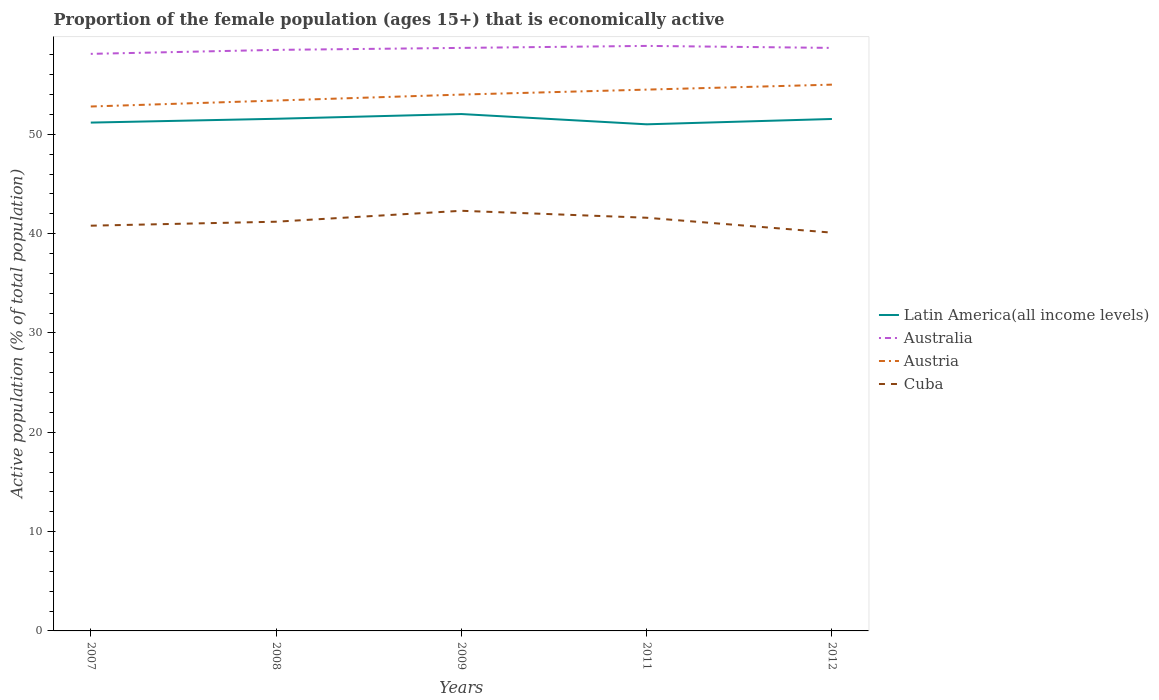Does the line corresponding to Latin America(all income levels) intersect with the line corresponding to Austria?
Offer a very short reply. No. Is the number of lines equal to the number of legend labels?
Make the answer very short. Yes. Across all years, what is the maximum proportion of the female population that is economically active in Australia?
Offer a very short reply. 58.1. What is the difference between the highest and the second highest proportion of the female population that is economically active in Latin America(all income levels)?
Offer a terse response. 1.03. What is the difference between the highest and the lowest proportion of the female population that is economically active in Austria?
Your answer should be compact. 3. How many years are there in the graph?
Offer a very short reply. 5. What is the difference between two consecutive major ticks on the Y-axis?
Make the answer very short. 10. Are the values on the major ticks of Y-axis written in scientific E-notation?
Provide a succinct answer. No. Where does the legend appear in the graph?
Your response must be concise. Center right. How many legend labels are there?
Make the answer very short. 4. How are the legend labels stacked?
Provide a succinct answer. Vertical. What is the title of the graph?
Offer a terse response. Proportion of the female population (ages 15+) that is economically active. Does "Malaysia" appear as one of the legend labels in the graph?
Offer a very short reply. No. What is the label or title of the Y-axis?
Your answer should be compact. Active population (% of total population). What is the Active population (% of total population) of Latin America(all income levels) in 2007?
Ensure brevity in your answer.  51.18. What is the Active population (% of total population) in Australia in 2007?
Keep it short and to the point. 58.1. What is the Active population (% of total population) of Austria in 2007?
Offer a very short reply. 52.8. What is the Active population (% of total population) in Cuba in 2007?
Make the answer very short. 40.8. What is the Active population (% of total population) in Latin America(all income levels) in 2008?
Your answer should be very brief. 51.56. What is the Active population (% of total population) of Australia in 2008?
Give a very brief answer. 58.5. What is the Active population (% of total population) of Austria in 2008?
Offer a terse response. 53.4. What is the Active population (% of total population) of Cuba in 2008?
Your response must be concise. 41.2. What is the Active population (% of total population) of Latin America(all income levels) in 2009?
Provide a succinct answer. 52.04. What is the Active population (% of total population) of Australia in 2009?
Offer a terse response. 58.7. What is the Active population (% of total population) in Austria in 2009?
Provide a short and direct response. 54. What is the Active population (% of total population) of Cuba in 2009?
Provide a short and direct response. 42.3. What is the Active population (% of total population) of Latin America(all income levels) in 2011?
Give a very brief answer. 51.01. What is the Active population (% of total population) of Australia in 2011?
Your answer should be very brief. 58.9. What is the Active population (% of total population) in Austria in 2011?
Keep it short and to the point. 54.5. What is the Active population (% of total population) of Cuba in 2011?
Offer a very short reply. 41.6. What is the Active population (% of total population) of Latin America(all income levels) in 2012?
Your response must be concise. 51.54. What is the Active population (% of total population) in Australia in 2012?
Your answer should be very brief. 58.7. What is the Active population (% of total population) of Cuba in 2012?
Give a very brief answer. 40.1. Across all years, what is the maximum Active population (% of total population) of Latin America(all income levels)?
Give a very brief answer. 52.04. Across all years, what is the maximum Active population (% of total population) of Australia?
Keep it short and to the point. 58.9. Across all years, what is the maximum Active population (% of total population) in Austria?
Your answer should be very brief. 55. Across all years, what is the maximum Active population (% of total population) in Cuba?
Offer a very short reply. 42.3. Across all years, what is the minimum Active population (% of total population) in Latin America(all income levels)?
Your answer should be very brief. 51.01. Across all years, what is the minimum Active population (% of total population) in Australia?
Ensure brevity in your answer.  58.1. Across all years, what is the minimum Active population (% of total population) in Austria?
Give a very brief answer. 52.8. Across all years, what is the minimum Active population (% of total population) in Cuba?
Make the answer very short. 40.1. What is the total Active population (% of total population) of Latin America(all income levels) in the graph?
Give a very brief answer. 257.33. What is the total Active population (% of total population) in Australia in the graph?
Your answer should be compact. 292.9. What is the total Active population (% of total population) in Austria in the graph?
Offer a very short reply. 269.7. What is the total Active population (% of total population) of Cuba in the graph?
Keep it short and to the point. 206. What is the difference between the Active population (% of total population) of Latin America(all income levels) in 2007 and that in 2008?
Your answer should be very brief. -0.38. What is the difference between the Active population (% of total population) in Australia in 2007 and that in 2008?
Ensure brevity in your answer.  -0.4. What is the difference between the Active population (% of total population) in Austria in 2007 and that in 2008?
Offer a terse response. -0.6. What is the difference between the Active population (% of total population) in Cuba in 2007 and that in 2008?
Your answer should be compact. -0.4. What is the difference between the Active population (% of total population) in Latin America(all income levels) in 2007 and that in 2009?
Give a very brief answer. -0.86. What is the difference between the Active population (% of total population) in Latin America(all income levels) in 2007 and that in 2011?
Your response must be concise. 0.17. What is the difference between the Active population (% of total population) in Latin America(all income levels) in 2007 and that in 2012?
Offer a terse response. -0.36. What is the difference between the Active population (% of total population) in Australia in 2007 and that in 2012?
Your answer should be compact. -0.6. What is the difference between the Active population (% of total population) of Austria in 2007 and that in 2012?
Make the answer very short. -2.2. What is the difference between the Active population (% of total population) in Cuba in 2007 and that in 2012?
Make the answer very short. 0.7. What is the difference between the Active population (% of total population) in Latin America(all income levels) in 2008 and that in 2009?
Provide a short and direct response. -0.48. What is the difference between the Active population (% of total population) of Australia in 2008 and that in 2009?
Your response must be concise. -0.2. What is the difference between the Active population (% of total population) in Cuba in 2008 and that in 2009?
Your response must be concise. -1.1. What is the difference between the Active population (% of total population) in Latin America(all income levels) in 2008 and that in 2011?
Offer a very short reply. 0.56. What is the difference between the Active population (% of total population) in Australia in 2008 and that in 2011?
Make the answer very short. -0.4. What is the difference between the Active population (% of total population) of Latin America(all income levels) in 2008 and that in 2012?
Offer a very short reply. 0.02. What is the difference between the Active population (% of total population) of Australia in 2008 and that in 2012?
Offer a very short reply. -0.2. What is the difference between the Active population (% of total population) in Cuba in 2008 and that in 2012?
Give a very brief answer. 1.1. What is the difference between the Active population (% of total population) of Latin America(all income levels) in 2009 and that in 2011?
Provide a succinct answer. 1.03. What is the difference between the Active population (% of total population) in Latin America(all income levels) in 2009 and that in 2012?
Provide a short and direct response. 0.5. What is the difference between the Active population (% of total population) in Cuba in 2009 and that in 2012?
Your answer should be very brief. 2.2. What is the difference between the Active population (% of total population) of Latin America(all income levels) in 2011 and that in 2012?
Provide a short and direct response. -0.54. What is the difference between the Active population (% of total population) of Australia in 2011 and that in 2012?
Your response must be concise. 0.2. What is the difference between the Active population (% of total population) of Latin America(all income levels) in 2007 and the Active population (% of total population) of Australia in 2008?
Offer a terse response. -7.32. What is the difference between the Active population (% of total population) of Latin America(all income levels) in 2007 and the Active population (% of total population) of Austria in 2008?
Provide a succinct answer. -2.22. What is the difference between the Active population (% of total population) of Latin America(all income levels) in 2007 and the Active population (% of total population) of Cuba in 2008?
Give a very brief answer. 9.98. What is the difference between the Active population (% of total population) in Australia in 2007 and the Active population (% of total population) in Cuba in 2008?
Offer a terse response. 16.9. What is the difference between the Active population (% of total population) of Austria in 2007 and the Active population (% of total population) of Cuba in 2008?
Provide a succinct answer. 11.6. What is the difference between the Active population (% of total population) of Latin America(all income levels) in 2007 and the Active population (% of total population) of Australia in 2009?
Ensure brevity in your answer.  -7.52. What is the difference between the Active population (% of total population) in Latin America(all income levels) in 2007 and the Active population (% of total population) in Austria in 2009?
Ensure brevity in your answer.  -2.82. What is the difference between the Active population (% of total population) in Latin America(all income levels) in 2007 and the Active population (% of total population) in Cuba in 2009?
Provide a short and direct response. 8.88. What is the difference between the Active population (% of total population) in Latin America(all income levels) in 2007 and the Active population (% of total population) in Australia in 2011?
Provide a succinct answer. -7.72. What is the difference between the Active population (% of total population) of Latin America(all income levels) in 2007 and the Active population (% of total population) of Austria in 2011?
Your response must be concise. -3.32. What is the difference between the Active population (% of total population) in Latin America(all income levels) in 2007 and the Active population (% of total population) in Cuba in 2011?
Give a very brief answer. 9.58. What is the difference between the Active population (% of total population) of Australia in 2007 and the Active population (% of total population) of Cuba in 2011?
Provide a succinct answer. 16.5. What is the difference between the Active population (% of total population) in Austria in 2007 and the Active population (% of total population) in Cuba in 2011?
Your response must be concise. 11.2. What is the difference between the Active population (% of total population) in Latin America(all income levels) in 2007 and the Active population (% of total population) in Australia in 2012?
Your response must be concise. -7.52. What is the difference between the Active population (% of total population) in Latin America(all income levels) in 2007 and the Active population (% of total population) in Austria in 2012?
Provide a succinct answer. -3.82. What is the difference between the Active population (% of total population) of Latin America(all income levels) in 2007 and the Active population (% of total population) of Cuba in 2012?
Offer a terse response. 11.08. What is the difference between the Active population (% of total population) of Austria in 2007 and the Active population (% of total population) of Cuba in 2012?
Your answer should be very brief. 12.7. What is the difference between the Active population (% of total population) in Latin America(all income levels) in 2008 and the Active population (% of total population) in Australia in 2009?
Provide a succinct answer. -7.14. What is the difference between the Active population (% of total population) of Latin America(all income levels) in 2008 and the Active population (% of total population) of Austria in 2009?
Keep it short and to the point. -2.44. What is the difference between the Active population (% of total population) in Latin America(all income levels) in 2008 and the Active population (% of total population) in Cuba in 2009?
Your answer should be compact. 9.26. What is the difference between the Active population (% of total population) in Latin America(all income levels) in 2008 and the Active population (% of total population) in Australia in 2011?
Ensure brevity in your answer.  -7.34. What is the difference between the Active population (% of total population) in Latin America(all income levels) in 2008 and the Active population (% of total population) in Austria in 2011?
Offer a terse response. -2.94. What is the difference between the Active population (% of total population) in Latin America(all income levels) in 2008 and the Active population (% of total population) in Cuba in 2011?
Your answer should be very brief. 9.96. What is the difference between the Active population (% of total population) of Australia in 2008 and the Active population (% of total population) of Austria in 2011?
Give a very brief answer. 4. What is the difference between the Active population (% of total population) of Latin America(all income levels) in 2008 and the Active population (% of total population) of Australia in 2012?
Your answer should be compact. -7.14. What is the difference between the Active population (% of total population) in Latin America(all income levels) in 2008 and the Active population (% of total population) in Austria in 2012?
Your response must be concise. -3.44. What is the difference between the Active population (% of total population) in Latin America(all income levels) in 2008 and the Active population (% of total population) in Cuba in 2012?
Give a very brief answer. 11.46. What is the difference between the Active population (% of total population) in Australia in 2008 and the Active population (% of total population) in Austria in 2012?
Make the answer very short. 3.5. What is the difference between the Active population (% of total population) of Australia in 2008 and the Active population (% of total population) of Cuba in 2012?
Make the answer very short. 18.4. What is the difference between the Active population (% of total population) of Latin America(all income levels) in 2009 and the Active population (% of total population) of Australia in 2011?
Offer a very short reply. -6.86. What is the difference between the Active population (% of total population) of Latin America(all income levels) in 2009 and the Active population (% of total population) of Austria in 2011?
Your answer should be very brief. -2.46. What is the difference between the Active population (% of total population) of Latin America(all income levels) in 2009 and the Active population (% of total population) of Cuba in 2011?
Ensure brevity in your answer.  10.44. What is the difference between the Active population (% of total population) of Australia in 2009 and the Active population (% of total population) of Austria in 2011?
Give a very brief answer. 4.2. What is the difference between the Active population (% of total population) of Latin America(all income levels) in 2009 and the Active population (% of total population) of Australia in 2012?
Offer a very short reply. -6.66. What is the difference between the Active population (% of total population) of Latin America(all income levels) in 2009 and the Active population (% of total population) of Austria in 2012?
Make the answer very short. -2.96. What is the difference between the Active population (% of total population) of Latin America(all income levels) in 2009 and the Active population (% of total population) of Cuba in 2012?
Your answer should be compact. 11.94. What is the difference between the Active population (% of total population) of Australia in 2009 and the Active population (% of total population) of Austria in 2012?
Ensure brevity in your answer.  3.7. What is the difference between the Active population (% of total population) of Australia in 2009 and the Active population (% of total population) of Cuba in 2012?
Give a very brief answer. 18.6. What is the difference between the Active population (% of total population) in Austria in 2009 and the Active population (% of total population) in Cuba in 2012?
Make the answer very short. 13.9. What is the difference between the Active population (% of total population) of Latin America(all income levels) in 2011 and the Active population (% of total population) of Australia in 2012?
Provide a short and direct response. -7.69. What is the difference between the Active population (% of total population) of Latin America(all income levels) in 2011 and the Active population (% of total population) of Austria in 2012?
Your answer should be very brief. -3.99. What is the difference between the Active population (% of total population) of Latin America(all income levels) in 2011 and the Active population (% of total population) of Cuba in 2012?
Offer a very short reply. 10.91. What is the difference between the Active population (% of total population) in Austria in 2011 and the Active population (% of total population) in Cuba in 2012?
Your answer should be very brief. 14.4. What is the average Active population (% of total population) of Latin America(all income levels) per year?
Offer a very short reply. 51.47. What is the average Active population (% of total population) of Australia per year?
Keep it short and to the point. 58.58. What is the average Active population (% of total population) of Austria per year?
Your answer should be very brief. 53.94. What is the average Active population (% of total population) of Cuba per year?
Give a very brief answer. 41.2. In the year 2007, what is the difference between the Active population (% of total population) in Latin America(all income levels) and Active population (% of total population) in Australia?
Make the answer very short. -6.92. In the year 2007, what is the difference between the Active population (% of total population) of Latin America(all income levels) and Active population (% of total population) of Austria?
Keep it short and to the point. -1.62. In the year 2007, what is the difference between the Active population (% of total population) of Latin America(all income levels) and Active population (% of total population) of Cuba?
Offer a terse response. 10.38. In the year 2007, what is the difference between the Active population (% of total population) in Australia and Active population (% of total population) in Cuba?
Provide a short and direct response. 17.3. In the year 2008, what is the difference between the Active population (% of total population) in Latin America(all income levels) and Active population (% of total population) in Australia?
Your answer should be compact. -6.94. In the year 2008, what is the difference between the Active population (% of total population) in Latin America(all income levels) and Active population (% of total population) in Austria?
Your answer should be very brief. -1.84. In the year 2008, what is the difference between the Active population (% of total population) in Latin America(all income levels) and Active population (% of total population) in Cuba?
Your answer should be very brief. 10.36. In the year 2008, what is the difference between the Active population (% of total population) in Australia and Active population (% of total population) in Cuba?
Offer a very short reply. 17.3. In the year 2008, what is the difference between the Active population (% of total population) in Austria and Active population (% of total population) in Cuba?
Keep it short and to the point. 12.2. In the year 2009, what is the difference between the Active population (% of total population) of Latin America(all income levels) and Active population (% of total population) of Australia?
Provide a succinct answer. -6.66. In the year 2009, what is the difference between the Active population (% of total population) in Latin America(all income levels) and Active population (% of total population) in Austria?
Provide a succinct answer. -1.96. In the year 2009, what is the difference between the Active population (% of total population) in Latin America(all income levels) and Active population (% of total population) in Cuba?
Keep it short and to the point. 9.74. In the year 2009, what is the difference between the Active population (% of total population) in Australia and Active population (% of total population) in Cuba?
Provide a succinct answer. 16.4. In the year 2009, what is the difference between the Active population (% of total population) in Austria and Active population (% of total population) in Cuba?
Ensure brevity in your answer.  11.7. In the year 2011, what is the difference between the Active population (% of total population) of Latin America(all income levels) and Active population (% of total population) of Australia?
Your answer should be very brief. -7.89. In the year 2011, what is the difference between the Active population (% of total population) of Latin America(all income levels) and Active population (% of total population) of Austria?
Offer a very short reply. -3.49. In the year 2011, what is the difference between the Active population (% of total population) of Latin America(all income levels) and Active population (% of total population) of Cuba?
Your answer should be compact. 9.41. In the year 2011, what is the difference between the Active population (% of total population) of Australia and Active population (% of total population) of Austria?
Give a very brief answer. 4.4. In the year 2011, what is the difference between the Active population (% of total population) in Australia and Active population (% of total population) in Cuba?
Provide a succinct answer. 17.3. In the year 2011, what is the difference between the Active population (% of total population) in Austria and Active population (% of total population) in Cuba?
Keep it short and to the point. 12.9. In the year 2012, what is the difference between the Active population (% of total population) in Latin America(all income levels) and Active population (% of total population) in Australia?
Give a very brief answer. -7.16. In the year 2012, what is the difference between the Active population (% of total population) in Latin America(all income levels) and Active population (% of total population) in Austria?
Offer a very short reply. -3.46. In the year 2012, what is the difference between the Active population (% of total population) of Latin America(all income levels) and Active population (% of total population) of Cuba?
Your response must be concise. 11.44. What is the ratio of the Active population (% of total population) in Austria in 2007 to that in 2008?
Provide a short and direct response. 0.99. What is the ratio of the Active population (% of total population) in Cuba in 2007 to that in 2008?
Keep it short and to the point. 0.99. What is the ratio of the Active population (% of total population) of Latin America(all income levels) in 2007 to that in 2009?
Offer a very short reply. 0.98. What is the ratio of the Active population (% of total population) in Austria in 2007 to that in 2009?
Provide a short and direct response. 0.98. What is the ratio of the Active population (% of total population) in Cuba in 2007 to that in 2009?
Offer a terse response. 0.96. What is the ratio of the Active population (% of total population) of Latin America(all income levels) in 2007 to that in 2011?
Give a very brief answer. 1. What is the ratio of the Active population (% of total population) of Australia in 2007 to that in 2011?
Provide a short and direct response. 0.99. What is the ratio of the Active population (% of total population) of Austria in 2007 to that in 2011?
Your answer should be very brief. 0.97. What is the ratio of the Active population (% of total population) in Cuba in 2007 to that in 2011?
Offer a very short reply. 0.98. What is the ratio of the Active population (% of total population) in Australia in 2007 to that in 2012?
Your response must be concise. 0.99. What is the ratio of the Active population (% of total population) in Austria in 2007 to that in 2012?
Give a very brief answer. 0.96. What is the ratio of the Active population (% of total population) of Cuba in 2007 to that in 2012?
Offer a very short reply. 1.02. What is the ratio of the Active population (% of total population) of Austria in 2008 to that in 2009?
Your answer should be very brief. 0.99. What is the ratio of the Active population (% of total population) in Cuba in 2008 to that in 2009?
Provide a short and direct response. 0.97. What is the ratio of the Active population (% of total population) in Latin America(all income levels) in 2008 to that in 2011?
Your answer should be compact. 1.01. What is the ratio of the Active population (% of total population) in Austria in 2008 to that in 2011?
Ensure brevity in your answer.  0.98. What is the ratio of the Active population (% of total population) of Austria in 2008 to that in 2012?
Make the answer very short. 0.97. What is the ratio of the Active population (% of total population) in Cuba in 2008 to that in 2012?
Your response must be concise. 1.03. What is the ratio of the Active population (% of total population) in Latin America(all income levels) in 2009 to that in 2011?
Give a very brief answer. 1.02. What is the ratio of the Active population (% of total population) of Cuba in 2009 to that in 2011?
Offer a very short reply. 1.02. What is the ratio of the Active population (% of total population) in Latin America(all income levels) in 2009 to that in 2012?
Your answer should be very brief. 1.01. What is the ratio of the Active population (% of total population) of Austria in 2009 to that in 2012?
Your answer should be very brief. 0.98. What is the ratio of the Active population (% of total population) of Cuba in 2009 to that in 2012?
Keep it short and to the point. 1.05. What is the ratio of the Active population (% of total population) of Austria in 2011 to that in 2012?
Make the answer very short. 0.99. What is the ratio of the Active population (% of total population) in Cuba in 2011 to that in 2012?
Your answer should be very brief. 1.04. What is the difference between the highest and the second highest Active population (% of total population) of Latin America(all income levels)?
Your response must be concise. 0.48. What is the difference between the highest and the second highest Active population (% of total population) of Australia?
Offer a very short reply. 0.2. What is the difference between the highest and the lowest Active population (% of total population) of Latin America(all income levels)?
Provide a succinct answer. 1.03. What is the difference between the highest and the lowest Active population (% of total population) of Australia?
Offer a terse response. 0.8. What is the difference between the highest and the lowest Active population (% of total population) of Austria?
Provide a short and direct response. 2.2. 